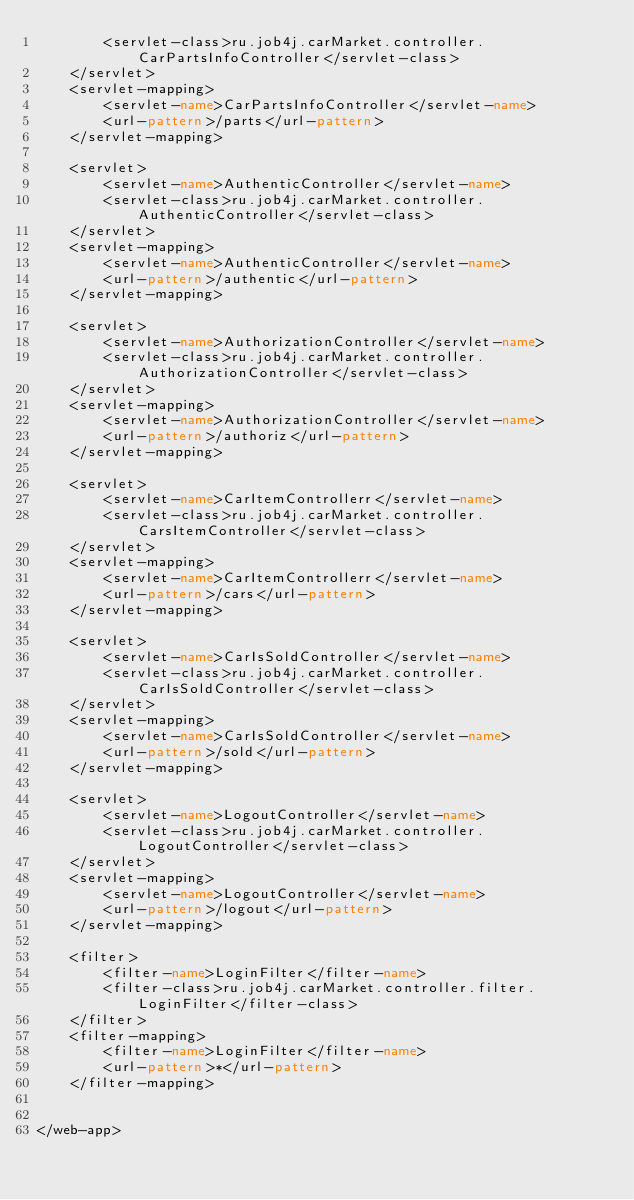<code> <loc_0><loc_0><loc_500><loc_500><_XML_>        <servlet-class>ru.job4j.carMarket.controller.CarPartsInfoController</servlet-class>
    </servlet>
    <servlet-mapping>
        <servlet-name>CarPartsInfoController</servlet-name>
        <url-pattern>/parts</url-pattern>
    </servlet-mapping>

    <servlet>
        <servlet-name>AuthenticController</servlet-name>
        <servlet-class>ru.job4j.carMarket.controller.AuthenticController</servlet-class>
    </servlet>
    <servlet-mapping>
        <servlet-name>AuthenticController</servlet-name>
        <url-pattern>/authentic</url-pattern>
    </servlet-mapping>

    <servlet>
        <servlet-name>AuthorizationController</servlet-name>
        <servlet-class>ru.job4j.carMarket.controller.AuthorizationController</servlet-class>
    </servlet>
    <servlet-mapping>
        <servlet-name>AuthorizationController</servlet-name>
        <url-pattern>/authoriz</url-pattern>
    </servlet-mapping>

    <servlet>
        <servlet-name>CarItemControllerr</servlet-name>
        <servlet-class>ru.job4j.carMarket.controller.CarsItemController</servlet-class>
    </servlet>
    <servlet-mapping>
        <servlet-name>CarItemControllerr</servlet-name>
        <url-pattern>/cars</url-pattern>
    </servlet-mapping>

    <servlet>
        <servlet-name>CarIsSoldController</servlet-name>
        <servlet-class>ru.job4j.carMarket.controller.CarIsSoldController</servlet-class>
    </servlet>
    <servlet-mapping>
        <servlet-name>CarIsSoldController</servlet-name>
        <url-pattern>/sold</url-pattern>
    </servlet-mapping>

    <servlet>
        <servlet-name>LogoutController</servlet-name>
        <servlet-class>ru.job4j.carMarket.controller.LogoutController</servlet-class>
    </servlet>
    <servlet-mapping>
        <servlet-name>LogoutController</servlet-name>
        <url-pattern>/logout</url-pattern>
    </servlet-mapping>

    <filter>
        <filter-name>LoginFilter</filter-name>
        <filter-class>ru.job4j.carMarket.controller.filter.LoginFilter</filter-class>
    </filter>
    <filter-mapping>
        <filter-name>LoginFilter</filter-name>
        <url-pattern>*</url-pattern>
    </filter-mapping>


</web-app></code> 